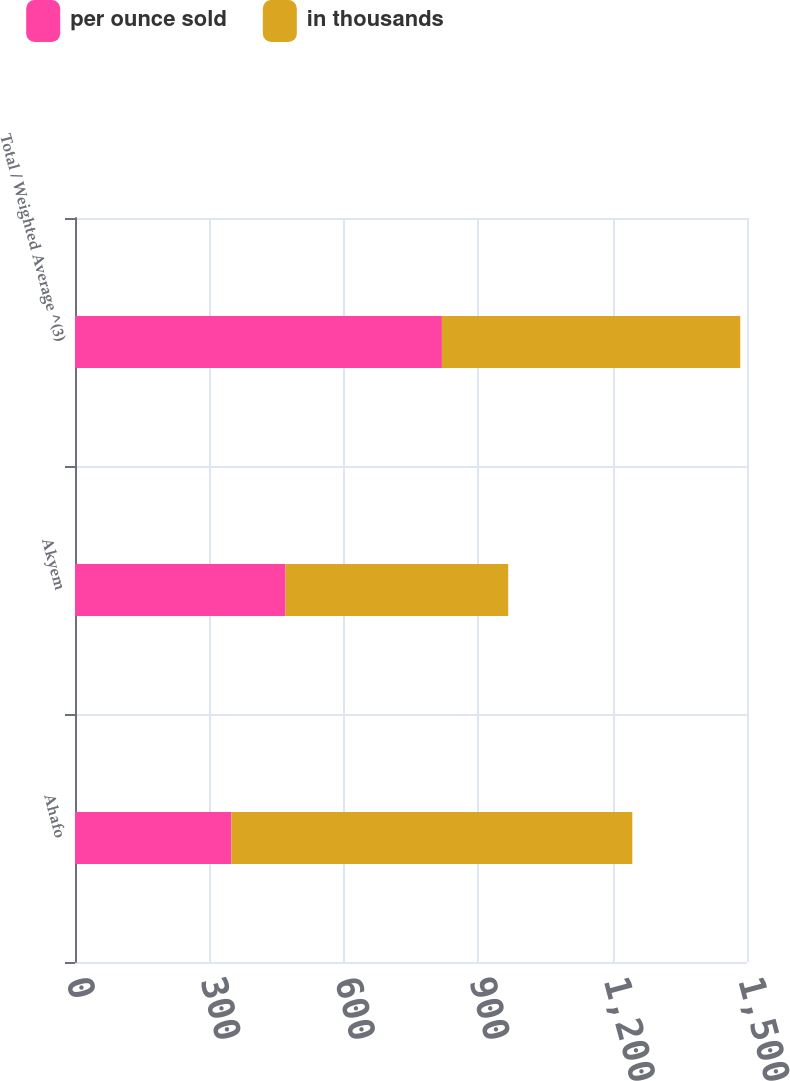Convert chart to OTSL. <chart><loc_0><loc_0><loc_500><loc_500><stacked_bar_chart><ecel><fcel>Ahafo<fcel>Akyem<fcel>Total / Weighted Average ^(3)<nl><fcel>per ounce sold<fcel>349<fcel>470<fcel>819<nl><fcel>in thousands<fcel>895<fcel>497<fcel>666<nl></chart> 